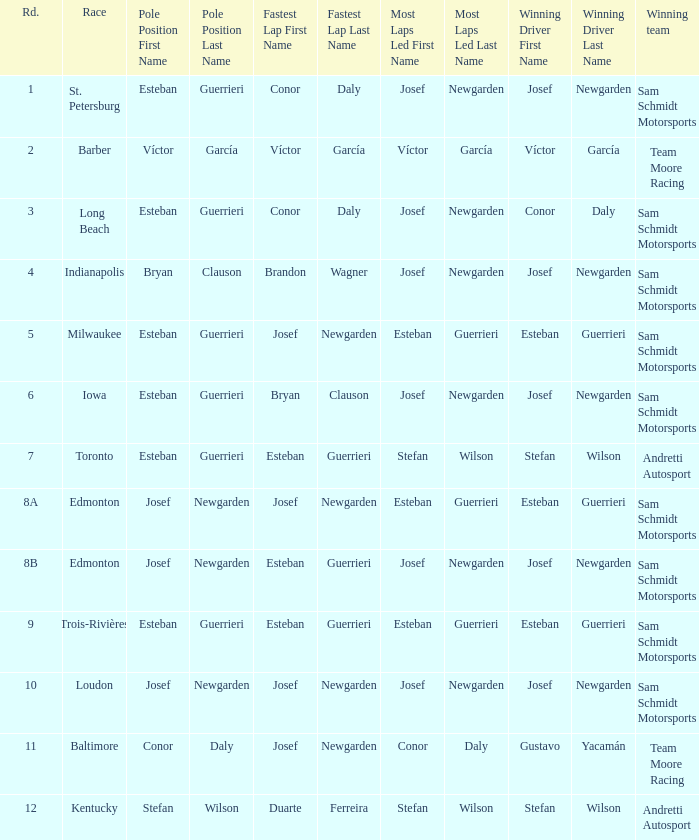What race did josef newgarden have the fastest lap and lead the most laps? Loudon. 